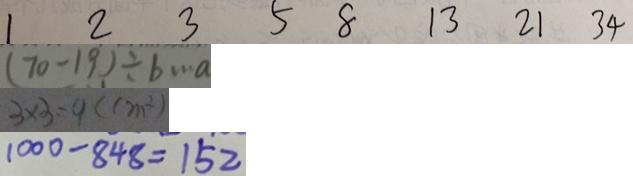<formula> <loc_0><loc_0><loc_500><loc_500>1 2 3 5 8 1 3 2 1 3 4 
 ( 7 0 - 1 9 ) \div b \cdots a 
 3 \times 3 = 9 ( c m ^ { 2 } ) 
 1 0 0 0 - 8 4 8 = 1 5 2</formula> 